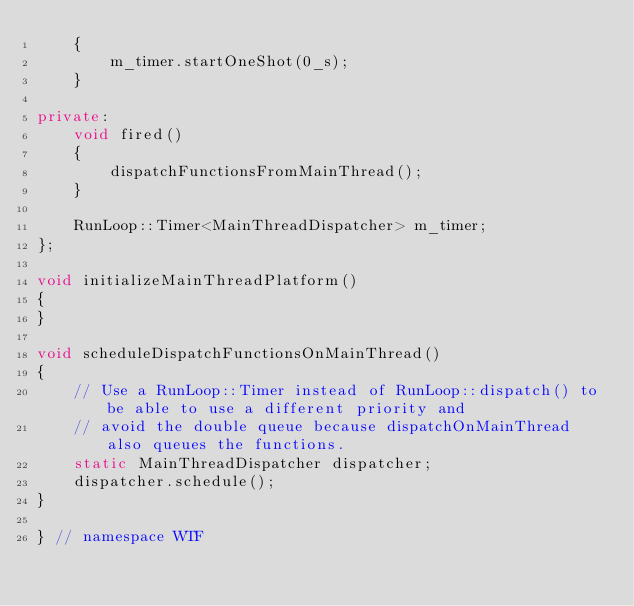Convert code to text. <code><loc_0><loc_0><loc_500><loc_500><_C++_>    {
        m_timer.startOneShot(0_s);
    }

private:
    void fired()
    {
        dispatchFunctionsFromMainThread();
    }

    RunLoop::Timer<MainThreadDispatcher> m_timer;
};

void initializeMainThreadPlatform()
{
}

void scheduleDispatchFunctionsOnMainThread()
{
    // Use a RunLoop::Timer instead of RunLoop::dispatch() to be able to use a different priority and
    // avoid the double queue because dispatchOnMainThread also queues the functions.
    static MainThreadDispatcher dispatcher;
    dispatcher.schedule();
}

} // namespace WTF
</code> 